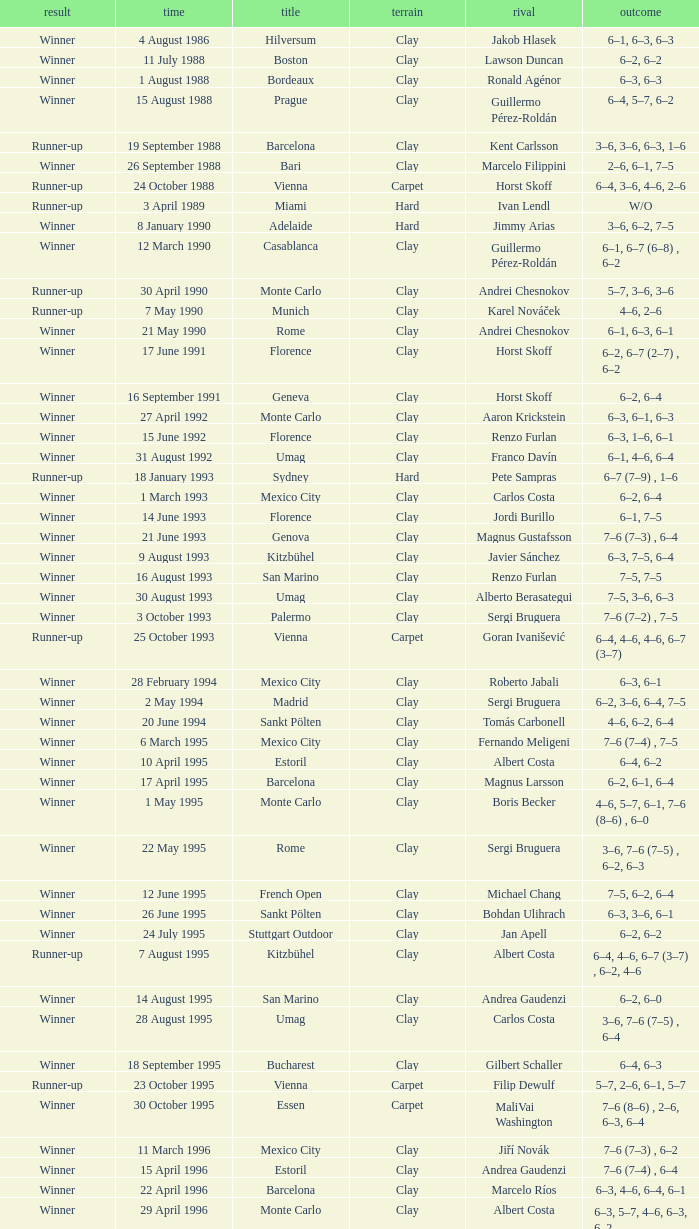Who is the opponent on 18 january 1993? Pete Sampras. Would you be able to parse every entry in this table? {'header': ['result', 'time', 'title', 'terrain', 'rival', 'outcome'], 'rows': [['Winner', '4 August 1986', 'Hilversum', 'Clay', 'Jakob Hlasek', '6–1, 6–3, 6–3'], ['Winner', '11 July 1988', 'Boston', 'Clay', 'Lawson Duncan', '6–2, 6–2'], ['Winner', '1 August 1988', 'Bordeaux', 'Clay', 'Ronald Agénor', '6–3, 6–3'], ['Winner', '15 August 1988', 'Prague', 'Clay', 'Guillermo Pérez-Roldán', '6–4, 5–7, 6–2'], ['Runner-up', '19 September 1988', 'Barcelona', 'Clay', 'Kent Carlsson', '3–6, 3–6, 6–3, 1–6'], ['Winner', '26 September 1988', 'Bari', 'Clay', 'Marcelo Filippini', '2–6, 6–1, 7–5'], ['Runner-up', '24 October 1988', 'Vienna', 'Carpet', 'Horst Skoff', '6–4, 3–6, 4–6, 2–6'], ['Runner-up', '3 April 1989', 'Miami', 'Hard', 'Ivan Lendl', 'W/O'], ['Winner', '8 January 1990', 'Adelaide', 'Hard', 'Jimmy Arias', '3–6, 6–2, 7–5'], ['Winner', '12 March 1990', 'Casablanca', 'Clay', 'Guillermo Pérez-Roldán', '6–1, 6–7 (6–8) , 6–2'], ['Runner-up', '30 April 1990', 'Monte Carlo', 'Clay', 'Andrei Chesnokov', '5–7, 3–6, 3–6'], ['Runner-up', '7 May 1990', 'Munich', 'Clay', 'Karel Nováček', '4–6, 2–6'], ['Winner', '21 May 1990', 'Rome', 'Clay', 'Andrei Chesnokov', '6–1, 6–3, 6–1'], ['Winner', '17 June 1991', 'Florence', 'Clay', 'Horst Skoff', '6–2, 6–7 (2–7) , 6–2'], ['Winner', '16 September 1991', 'Geneva', 'Clay', 'Horst Skoff', '6–2, 6–4'], ['Winner', '27 April 1992', 'Monte Carlo', 'Clay', 'Aaron Krickstein', '6–3, 6–1, 6–3'], ['Winner', '15 June 1992', 'Florence', 'Clay', 'Renzo Furlan', '6–3, 1–6, 6–1'], ['Winner', '31 August 1992', 'Umag', 'Clay', 'Franco Davín', '6–1, 4–6, 6–4'], ['Runner-up', '18 January 1993', 'Sydney', 'Hard', 'Pete Sampras', '6–7 (7–9) , 1–6'], ['Winner', '1 March 1993', 'Mexico City', 'Clay', 'Carlos Costa', '6–2, 6–4'], ['Winner', '14 June 1993', 'Florence', 'Clay', 'Jordi Burillo', '6–1, 7–5'], ['Winner', '21 June 1993', 'Genova', 'Clay', 'Magnus Gustafsson', '7–6 (7–3) , 6–4'], ['Winner', '9 August 1993', 'Kitzbühel', 'Clay', 'Javier Sánchez', '6–3, 7–5, 6–4'], ['Winner', '16 August 1993', 'San Marino', 'Clay', 'Renzo Furlan', '7–5, 7–5'], ['Winner', '30 August 1993', 'Umag', 'Clay', 'Alberto Berasategui', '7–5, 3–6, 6–3'], ['Winner', '3 October 1993', 'Palermo', 'Clay', 'Sergi Bruguera', '7–6 (7–2) , 7–5'], ['Runner-up', '25 October 1993', 'Vienna', 'Carpet', 'Goran Ivanišević', '6–4, 4–6, 4–6, 6–7 (3–7)'], ['Winner', '28 February 1994', 'Mexico City', 'Clay', 'Roberto Jabali', '6–3, 6–1'], ['Winner', '2 May 1994', 'Madrid', 'Clay', 'Sergi Bruguera', '6–2, 3–6, 6–4, 7–5'], ['Winner', '20 June 1994', 'Sankt Pölten', 'Clay', 'Tomás Carbonell', '4–6, 6–2, 6–4'], ['Winner', '6 March 1995', 'Mexico City', 'Clay', 'Fernando Meligeni', '7–6 (7–4) , 7–5'], ['Winner', '10 April 1995', 'Estoril', 'Clay', 'Albert Costa', '6–4, 6–2'], ['Winner', '17 April 1995', 'Barcelona', 'Clay', 'Magnus Larsson', '6–2, 6–1, 6–4'], ['Winner', '1 May 1995', 'Monte Carlo', 'Clay', 'Boris Becker', '4–6, 5–7, 6–1, 7–6 (8–6) , 6–0'], ['Winner', '22 May 1995', 'Rome', 'Clay', 'Sergi Bruguera', '3–6, 7–6 (7–5) , 6–2, 6–3'], ['Winner', '12 June 1995', 'French Open', 'Clay', 'Michael Chang', '7–5, 6–2, 6–4'], ['Winner', '26 June 1995', 'Sankt Pölten', 'Clay', 'Bohdan Ulihrach', '6–3, 3–6, 6–1'], ['Winner', '24 July 1995', 'Stuttgart Outdoor', 'Clay', 'Jan Apell', '6–2, 6–2'], ['Runner-up', '7 August 1995', 'Kitzbühel', 'Clay', 'Albert Costa', '6–4, 4–6, 6–7 (3–7) , 6–2, 4–6'], ['Winner', '14 August 1995', 'San Marino', 'Clay', 'Andrea Gaudenzi', '6–2, 6–0'], ['Winner', '28 August 1995', 'Umag', 'Clay', 'Carlos Costa', '3–6, 7–6 (7–5) , 6–4'], ['Winner', '18 September 1995', 'Bucharest', 'Clay', 'Gilbert Schaller', '6–4, 6–3'], ['Runner-up', '23 October 1995', 'Vienna', 'Carpet', 'Filip Dewulf', '5–7, 2–6, 6–1, 5–7'], ['Winner', '30 October 1995', 'Essen', 'Carpet', 'MaliVai Washington', '7–6 (8–6) , 2–6, 6–3, 6–4'], ['Winner', '11 March 1996', 'Mexico City', 'Clay', 'Jiří Novák', '7–6 (7–3) , 6–2'], ['Winner', '15 April 1996', 'Estoril', 'Clay', 'Andrea Gaudenzi', '7–6 (7–4) , 6–4'], ['Winner', '22 April 1996', 'Barcelona', 'Clay', 'Marcelo Ríos', '6–3, 4–6, 6–4, 6–1'], ['Winner', '29 April 1996', 'Monte Carlo', 'Clay', 'Albert Costa', '6–3, 5–7, 4–6, 6–3, 6–2'], ['Winner', '20 May 1996', 'Rome', 'Clay', 'Richard Krajicek', '6–2, 6–4, 3–6, 6–3'], ['Winner', '22 July 1996', 'Stuttgart Outdoor', 'Clay', 'Yevgeny Kafelnikov', '6–2, 6–2, 6–4'], ['Winner', '16 September 1996', 'Bogotá', 'Clay', 'Nicolás Lapentti', '6–7 (6–8) , 6–2, 6–3'], ['Winner', '17 February 1997', 'Dubai', 'Hard', 'Goran Ivanišević', '7–5, 7–6 (7–3)'], ['Winner', '31 March 1997', 'Miami', 'Hard', 'Sergi Bruguera', '7–6 (8–6) , 6–3, 6–1'], ['Runner-up', '11 August 1997', 'Cincinnati', 'Hard', 'Pete Sampras', '3–6, 4–6'], ['Runner-up', '13 April 1998', 'Estoril', 'Clay', 'Alberto Berasategui', '6–3, 1–6, 3–6']]} 